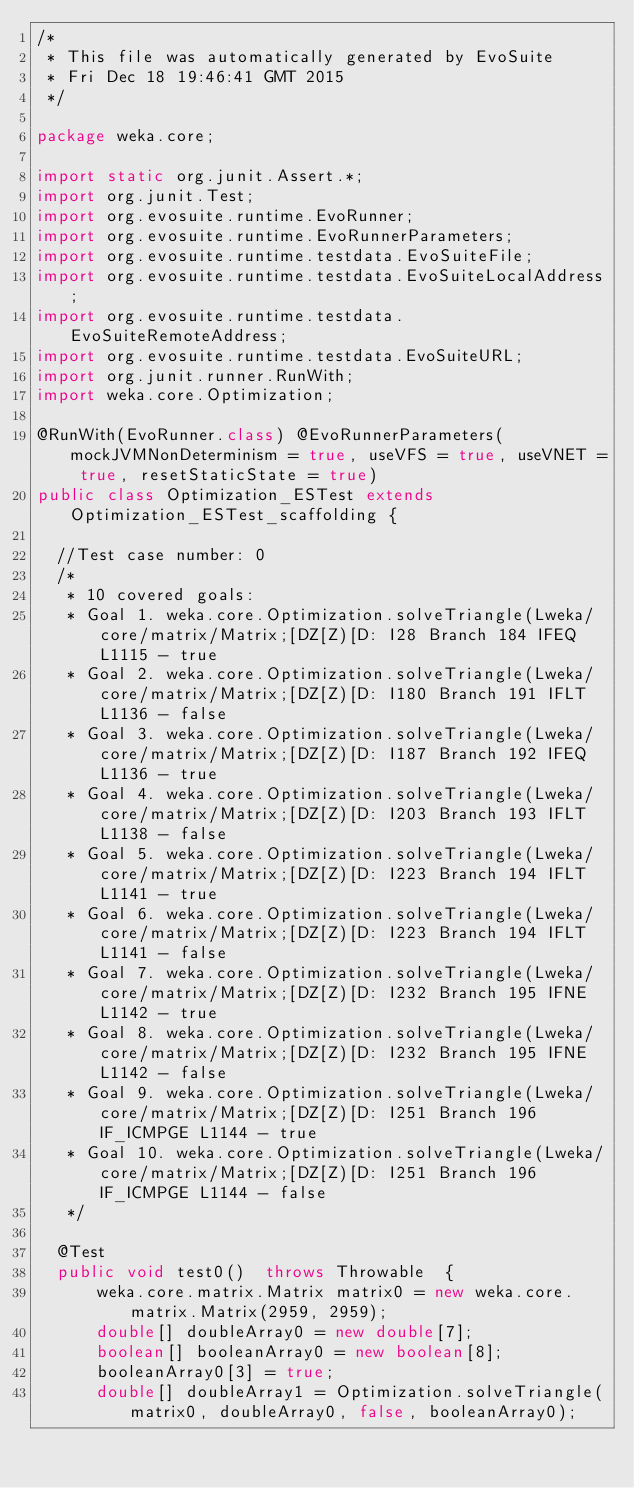Convert code to text. <code><loc_0><loc_0><loc_500><loc_500><_Java_>/*
 * This file was automatically generated by EvoSuite
 * Fri Dec 18 19:46:41 GMT 2015
 */

package weka.core;

import static org.junit.Assert.*;
import org.junit.Test;
import org.evosuite.runtime.EvoRunner;
import org.evosuite.runtime.EvoRunnerParameters;
import org.evosuite.runtime.testdata.EvoSuiteFile;
import org.evosuite.runtime.testdata.EvoSuiteLocalAddress;
import org.evosuite.runtime.testdata.EvoSuiteRemoteAddress;
import org.evosuite.runtime.testdata.EvoSuiteURL;
import org.junit.runner.RunWith;
import weka.core.Optimization;

@RunWith(EvoRunner.class) @EvoRunnerParameters(mockJVMNonDeterminism = true, useVFS = true, useVNET = true, resetStaticState = true) 
public class Optimization_ESTest extends Optimization_ESTest_scaffolding {

  //Test case number: 0
  /*
   * 10 covered goals:
   * Goal 1. weka.core.Optimization.solveTriangle(Lweka/core/matrix/Matrix;[DZ[Z)[D: I28 Branch 184 IFEQ L1115 - true
   * Goal 2. weka.core.Optimization.solveTriangle(Lweka/core/matrix/Matrix;[DZ[Z)[D: I180 Branch 191 IFLT L1136 - false
   * Goal 3. weka.core.Optimization.solveTriangle(Lweka/core/matrix/Matrix;[DZ[Z)[D: I187 Branch 192 IFEQ L1136 - true
   * Goal 4. weka.core.Optimization.solveTriangle(Lweka/core/matrix/Matrix;[DZ[Z)[D: I203 Branch 193 IFLT L1138 - false
   * Goal 5. weka.core.Optimization.solveTriangle(Lweka/core/matrix/Matrix;[DZ[Z)[D: I223 Branch 194 IFLT L1141 - true
   * Goal 6. weka.core.Optimization.solveTriangle(Lweka/core/matrix/Matrix;[DZ[Z)[D: I223 Branch 194 IFLT L1141 - false
   * Goal 7. weka.core.Optimization.solveTriangle(Lweka/core/matrix/Matrix;[DZ[Z)[D: I232 Branch 195 IFNE L1142 - true
   * Goal 8. weka.core.Optimization.solveTriangle(Lweka/core/matrix/Matrix;[DZ[Z)[D: I232 Branch 195 IFNE L1142 - false
   * Goal 9. weka.core.Optimization.solveTriangle(Lweka/core/matrix/Matrix;[DZ[Z)[D: I251 Branch 196 IF_ICMPGE L1144 - true
   * Goal 10. weka.core.Optimization.solveTriangle(Lweka/core/matrix/Matrix;[DZ[Z)[D: I251 Branch 196 IF_ICMPGE L1144 - false
   */

  @Test
  public void test0()  throws Throwable  {
      weka.core.matrix.Matrix matrix0 = new weka.core.matrix.Matrix(2959, 2959);
      double[] doubleArray0 = new double[7];
      boolean[] booleanArray0 = new boolean[8];
      booleanArray0[3] = true;
      double[] doubleArray1 = Optimization.solveTriangle(matrix0, doubleArray0, false, booleanArray0);</code> 